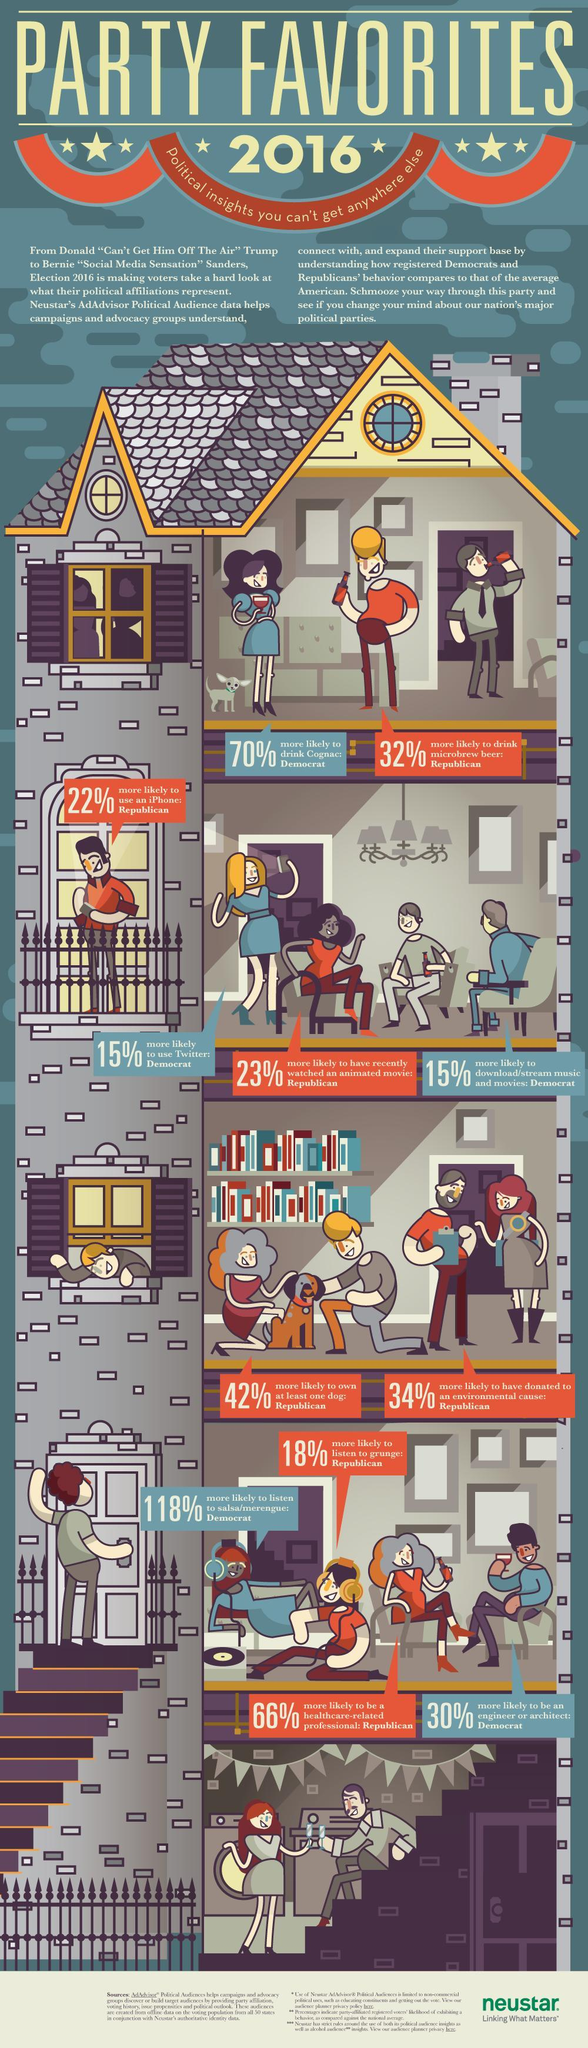What is the interest of democrats regarding movies?
Answer the question with a short phrase. download/stream music and movies What is the inverse of percentage of Democrats who are interested in Twitter? 85 